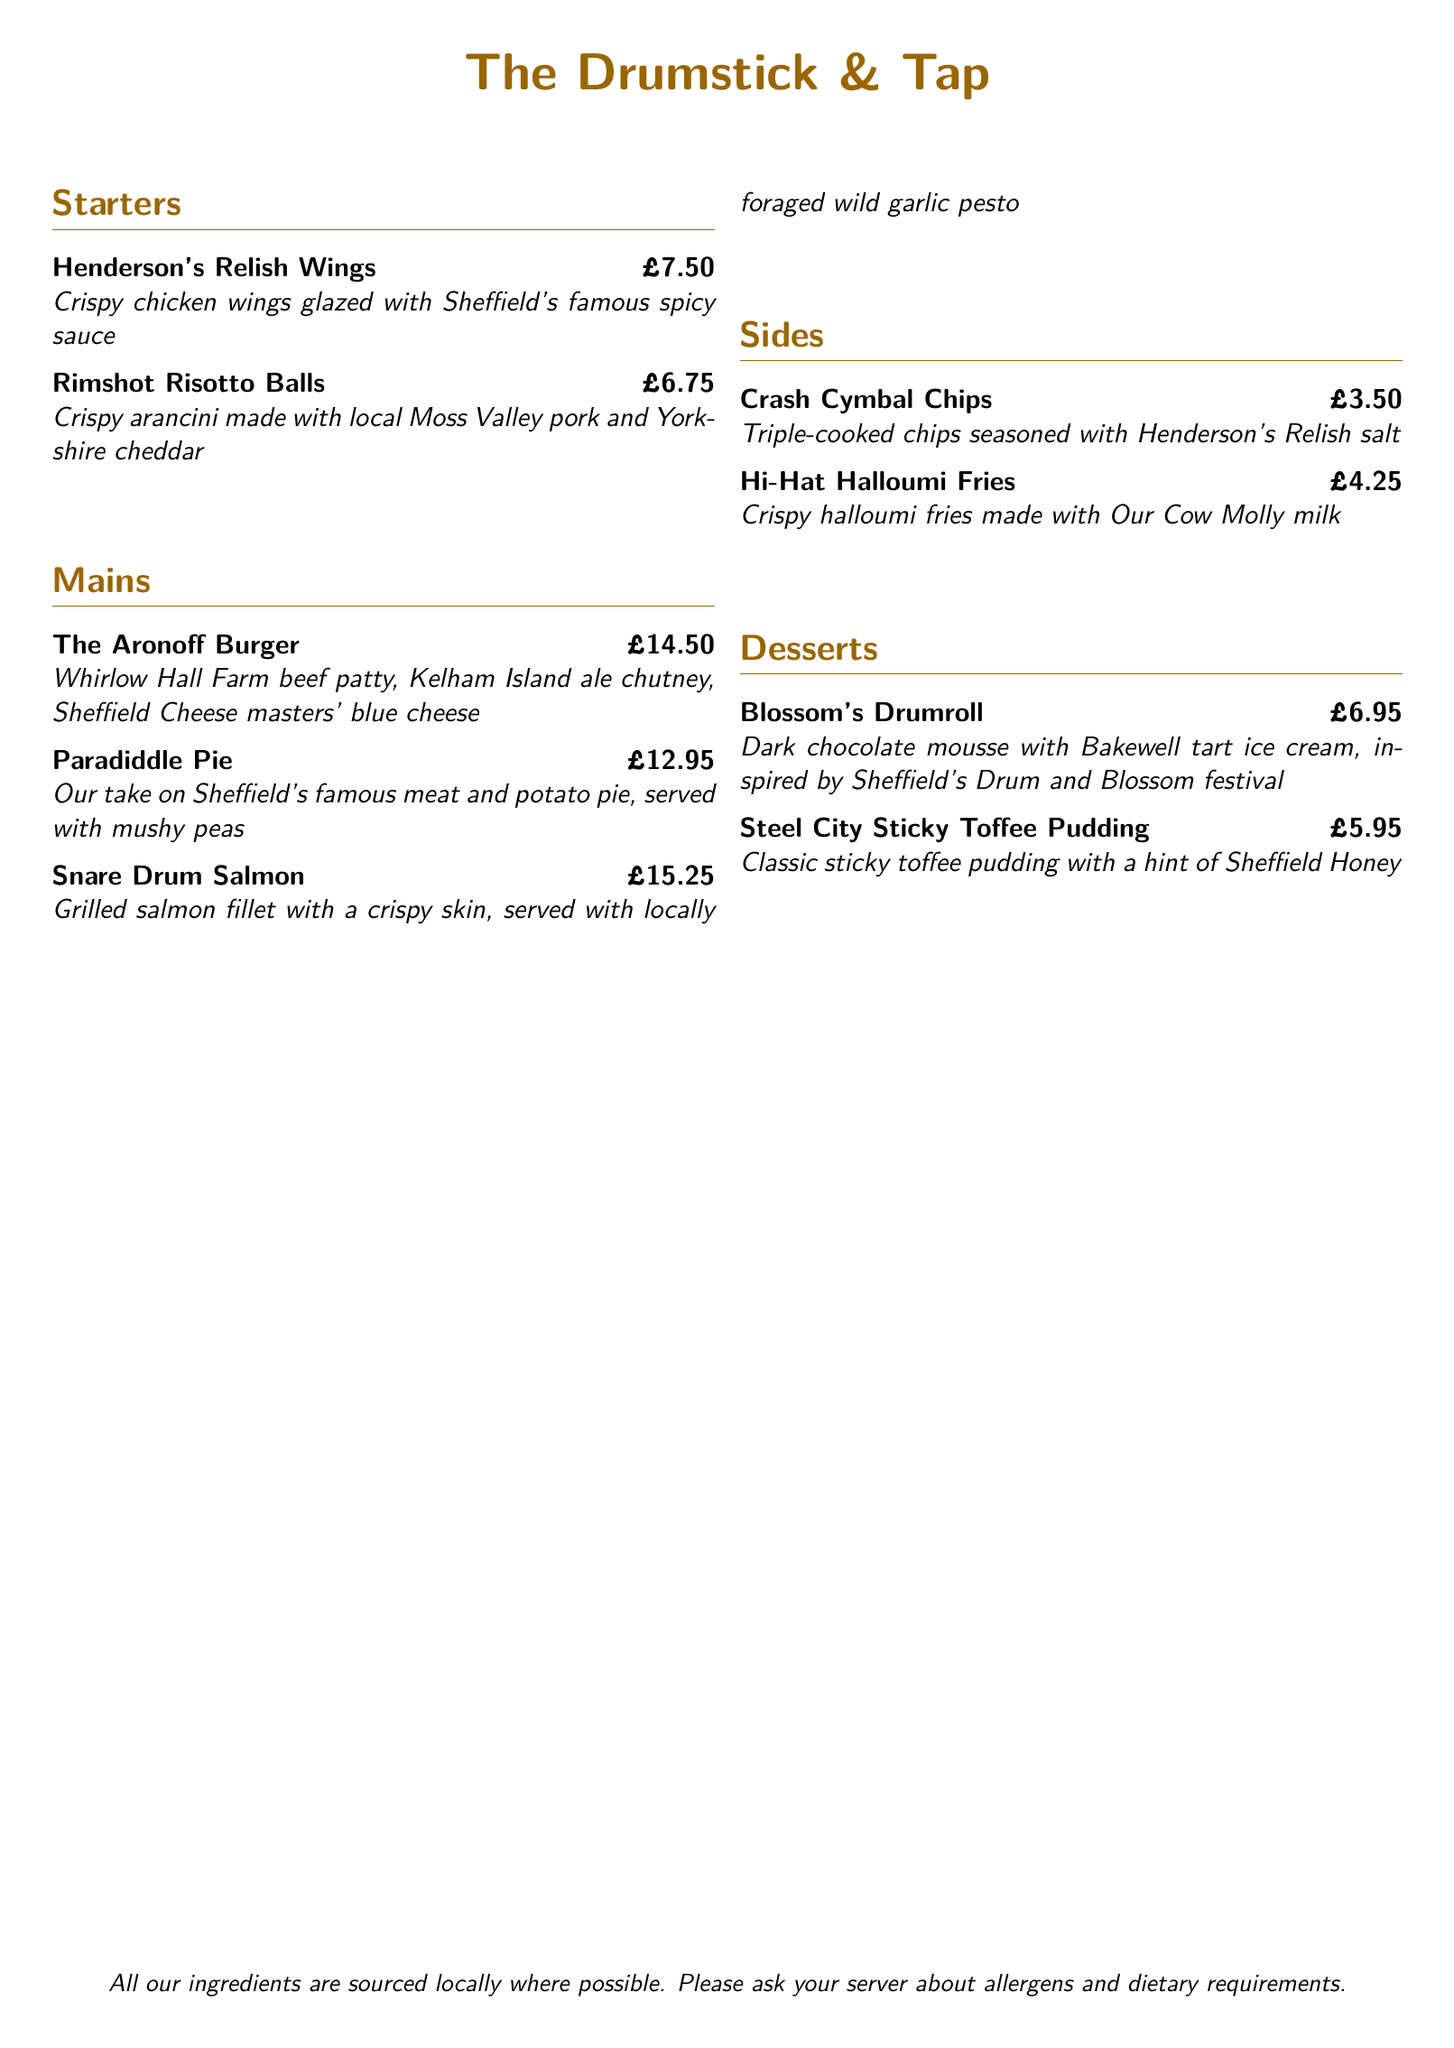What is the name of the restaurant? The name of the restaurant is prominently displayed at the center of the menu.
Answer: The Drumstick & Tap How much do the Cherry’s Drumroll and Steel City Sticky Toffee Pudding cost? The prices can be found next to each dessert on the menu.
Answer: £6.95, £5.95 Which side dish is made with Henderson's Relish salt? This information is listed in the sides section of the menu.
Answer: Crash Cymbal Chips What type of fish is featured in the Snare Drum Salmon? The main ingredient for this dish is stated in the name itself as well as the description.
Answer: Salmon How many starters are on the menu? The number of starter items can be counted in the starters section.
Answer: 2 Which meat is used in the Rimshot Risotto Balls? The specific type of meat is mentioned in the description of the dish.
Answer: Moss Valley pork What is the main ingredient in the Aronoff Burger? The key ingredient is highlighted in the name and description of the main dish.
Answer: Whirlow Hall Farm beef patty What dessert is inspired by a festival in Sheffield? The dessert's name and description provide clues about its inspiration.
Answer: Blossom's Drumroll What is a common theme for the names of the dishes? The names of the dishes reflect a significant cultural element related to the restaurant's theme.
Answer: Drum-related themes 